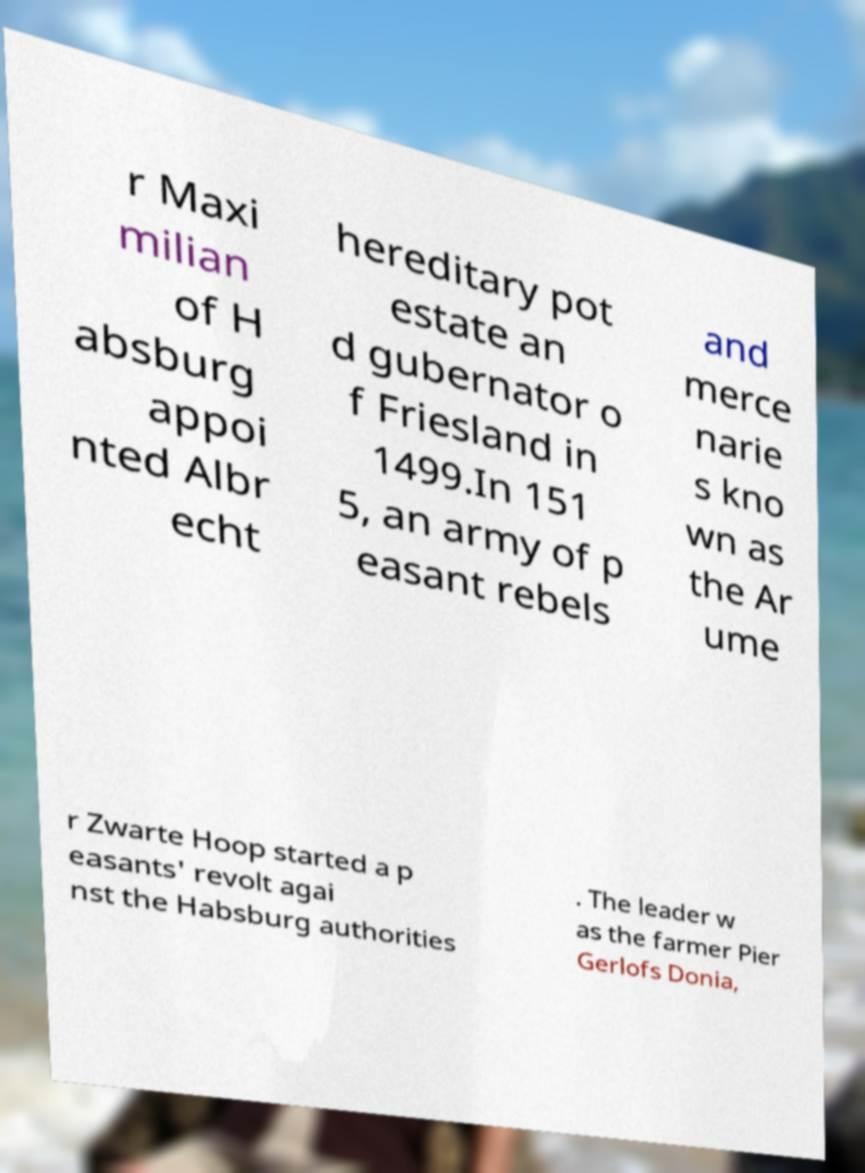What messages or text are displayed in this image? I need them in a readable, typed format. r Maxi milian of H absburg appoi nted Albr echt hereditary pot estate an d gubernator o f Friesland in 1499.In 151 5, an army of p easant rebels and merce narie s kno wn as the Ar ume r Zwarte Hoop started a p easants' revolt agai nst the Habsburg authorities . The leader w as the farmer Pier Gerlofs Donia, 